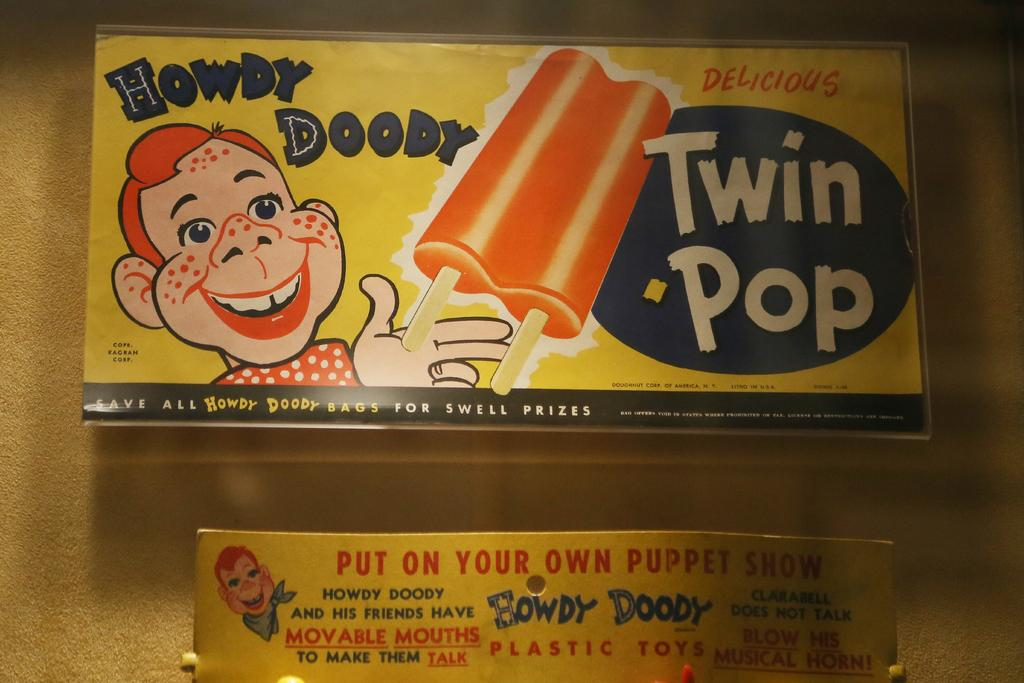How many boards are in the image? There are two boards in the image. What is depicted on the boards? There are two ice creams depicted on the boards. What type of faces are present on the boards? Cartoon faces are present on the boards. What can be found written on the boards? There is text written on the boards. Where are the boards attached in the image? The boards are attached to a yellow wall. How many friends are shown folding their degrees in the image? There are no friends, folding, or degrees present in the image. 